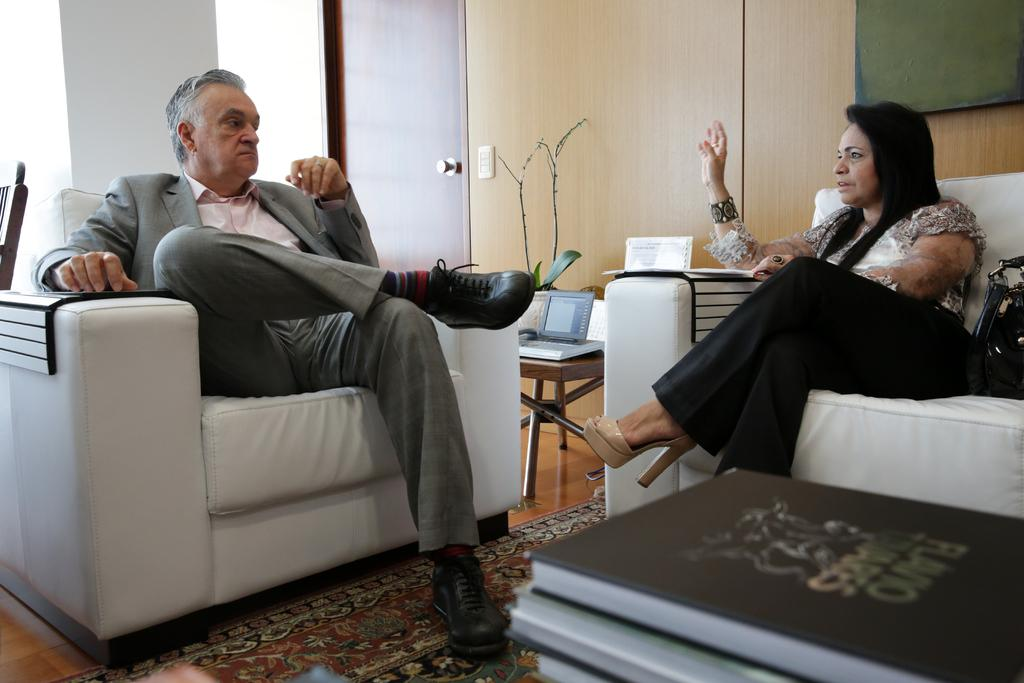What are the people in the image doing? There is a man and a woman sitting on the couch in the image. What can be seen in the background of the image? There is a wall and a plant in the background of the image. What month is it in the image? The month cannot be determined from the image, as there is no information about the time of year or any seasonal elements present. --- Facts: 1. There is a car in the image. 2. The car is red. 3. The car has four wheels. 4. There is a road in the image. 5. The road is paved. Absurd Topics: bird, ocean, mountain Conversation: What is the main subject of the image? The main subject of the image is a car. What color is the car? The car is red. How many wheels does the car have? The car has four wheels. What can be seen in the background of the image? There is a road in the image, and it is paved. Reasoning: Let's think step by step in order to produce the conversation. We start by identifying the main subject of the image, which is the car. Then, we describe specific features of the car, such as its color and the number of wheels. Finally, we describe the background elements, noting that there is a road and that it is paved. Absurd Question/Answer: Can you see any mountains in the image? No, there are no mountains visible in the image. 